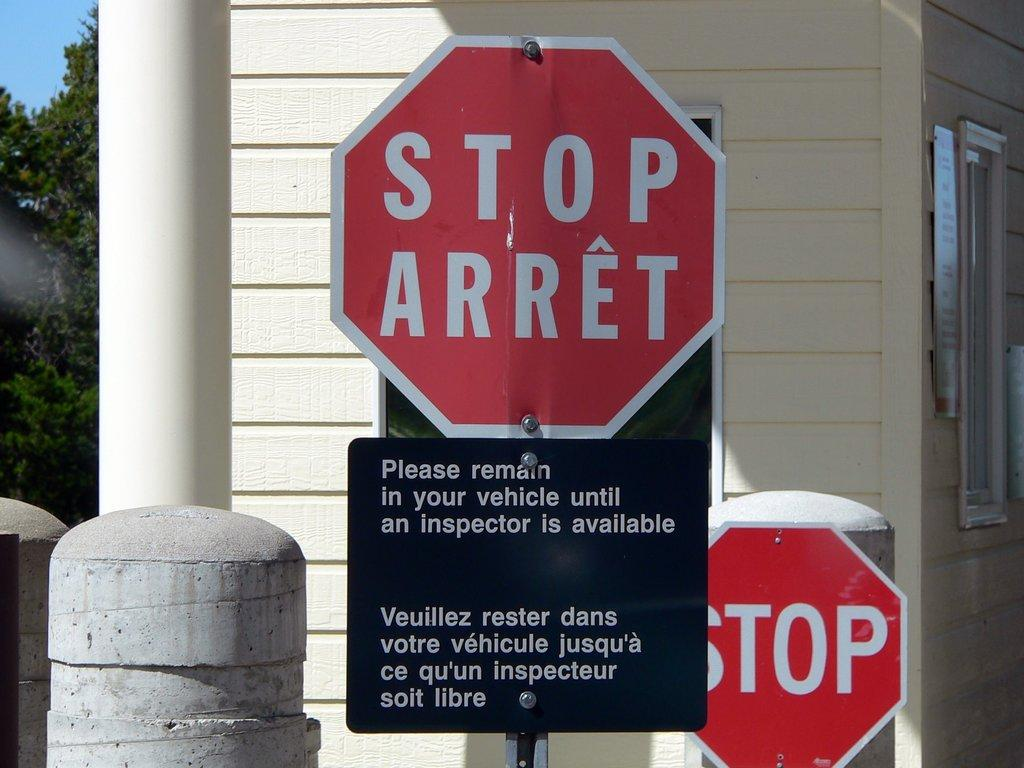Provide a one-sentence caption for the provided image. Vehicles are required to stop and be inspected before entry. 